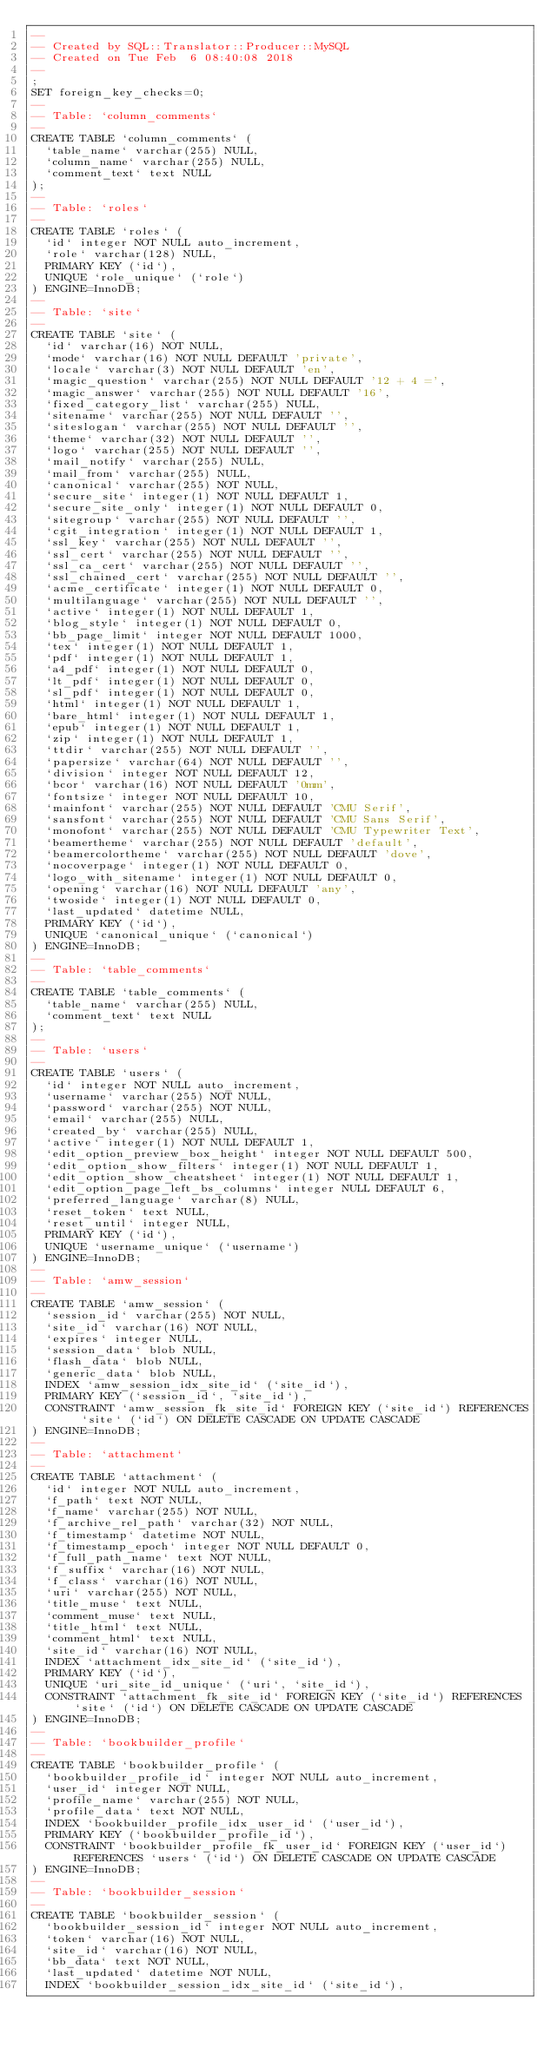<code> <loc_0><loc_0><loc_500><loc_500><_SQL_>-- 
-- Created by SQL::Translator::Producer::MySQL
-- Created on Tue Feb  6 08:40:08 2018
-- 
;
SET foreign_key_checks=0;
--
-- Table: `column_comments`
--
CREATE TABLE `column_comments` (
  `table_name` varchar(255) NULL,
  `column_name` varchar(255) NULL,
  `comment_text` text NULL
);
--
-- Table: `roles`
--
CREATE TABLE `roles` (
  `id` integer NOT NULL auto_increment,
  `role` varchar(128) NULL,
  PRIMARY KEY (`id`),
  UNIQUE `role_unique` (`role`)
) ENGINE=InnoDB;
--
-- Table: `site`
--
CREATE TABLE `site` (
  `id` varchar(16) NOT NULL,
  `mode` varchar(16) NOT NULL DEFAULT 'private',
  `locale` varchar(3) NOT NULL DEFAULT 'en',
  `magic_question` varchar(255) NOT NULL DEFAULT '12 + 4 =',
  `magic_answer` varchar(255) NOT NULL DEFAULT '16',
  `fixed_category_list` varchar(255) NULL,
  `sitename` varchar(255) NOT NULL DEFAULT '',
  `siteslogan` varchar(255) NOT NULL DEFAULT '',
  `theme` varchar(32) NOT NULL DEFAULT '',
  `logo` varchar(255) NOT NULL DEFAULT '',
  `mail_notify` varchar(255) NULL,
  `mail_from` varchar(255) NULL,
  `canonical` varchar(255) NOT NULL,
  `secure_site` integer(1) NOT NULL DEFAULT 1,
  `secure_site_only` integer(1) NOT NULL DEFAULT 0,
  `sitegroup` varchar(255) NOT NULL DEFAULT '',
  `cgit_integration` integer(1) NOT NULL DEFAULT 1,
  `ssl_key` varchar(255) NOT NULL DEFAULT '',
  `ssl_cert` varchar(255) NOT NULL DEFAULT '',
  `ssl_ca_cert` varchar(255) NOT NULL DEFAULT '',
  `ssl_chained_cert` varchar(255) NOT NULL DEFAULT '',
  `acme_certificate` integer(1) NOT NULL DEFAULT 0,
  `multilanguage` varchar(255) NOT NULL DEFAULT '',
  `active` integer(1) NOT NULL DEFAULT 1,
  `blog_style` integer(1) NOT NULL DEFAULT 0,
  `bb_page_limit` integer NOT NULL DEFAULT 1000,
  `tex` integer(1) NOT NULL DEFAULT 1,
  `pdf` integer(1) NOT NULL DEFAULT 1,
  `a4_pdf` integer(1) NOT NULL DEFAULT 0,
  `lt_pdf` integer(1) NOT NULL DEFAULT 0,
  `sl_pdf` integer(1) NOT NULL DEFAULT 0,
  `html` integer(1) NOT NULL DEFAULT 1,
  `bare_html` integer(1) NOT NULL DEFAULT 1,
  `epub` integer(1) NOT NULL DEFAULT 1,
  `zip` integer(1) NOT NULL DEFAULT 1,
  `ttdir` varchar(255) NOT NULL DEFAULT '',
  `papersize` varchar(64) NOT NULL DEFAULT '',
  `division` integer NOT NULL DEFAULT 12,
  `bcor` varchar(16) NOT NULL DEFAULT '0mm',
  `fontsize` integer NOT NULL DEFAULT 10,
  `mainfont` varchar(255) NOT NULL DEFAULT 'CMU Serif',
  `sansfont` varchar(255) NOT NULL DEFAULT 'CMU Sans Serif',
  `monofont` varchar(255) NOT NULL DEFAULT 'CMU Typewriter Text',
  `beamertheme` varchar(255) NOT NULL DEFAULT 'default',
  `beamercolortheme` varchar(255) NOT NULL DEFAULT 'dove',
  `nocoverpage` integer(1) NOT NULL DEFAULT 0,
  `logo_with_sitename` integer(1) NOT NULL DEFAULT 0,
  `opening` varchar(16) NOT NULL DEFAULT 'any',
  `twoside` integer(1) NOT NULL DEFAULT 0,
  `last_updated` datetime NULL,
  PRIMARY KEY (`id`),
  UNIQUE `canonical_unique` (`canonical`)
) ENGINE=InnoDB;
--
-- Table: `table_comments`
--
CREATE TABLE `table_comments` (
  `table_name` varchar(255) NULL,
  `comment_text` text NULL
);
--
-- Table: `users`
--
CREATE TABLE `users` (
  `id` integer NOT NULL auto_increment,
  `username` varchar(255) NOT NULL,
  `password` varchar(255) NOT NULL,
  `email` varchar(255) NULL,
  `created_by` varchar(255) NULL,
  `active` integer(1) NOT NULL DEFAULT 1,
  `edit_option_preview_box_height` integer NOT NULL DEFAULT 500,
  `edit_option_show_filters` integer(1) NOT NULL DEFAULT 1,
  `edit_option_show_cheatsheet` integer(1) NOT NULL DEFAULT 1,
  `edit_option_page_left_bs_columns` integer NULL DEFAULT 6,
  `preferred_language` varchar(8) NULL,
  `reset_token` text NULL,
  `reset_until` integer NULL,
  PRIMARY KEY (`id`),
  UNIQUE `username_unique` (`username`)
) ENGINE=InnoDB;
--
-- Table: `amw_session`
--
CREATE TABLE `amw_session` (
  `session_id` varchar(255) NOT NULL,
  `site_id` varchar(16) NOT NULL,
  `expires` integer NULL,
  `session_data` blob NULL,
  `flash_data` blob NULL,
  `generic_data` blob NULL,
  INDEX `amw_session_idx_site_id` (`site_id`),
  PRIMARY KEY (`session_id`, `site_id`),
  CONSTRAINT `amw_session_fk_site_id` FOREIGN KEY (`site_id`) REFERENCES `site` (`id`) ON DELETE CASCADE ON UPDATE CASCADE
) ENGINE=InnoDB;
--
-- Table: `attachment`
--
CREATE TABLE `attachment` (
  `id` integer NOT NULL auto_increment,
  `f_path` text NOT NULL,
  `f_name` varchar(255) NOT NULL,
  `f_archive_rel_path` varchar(32) NOT NULL,
  `f_timestamp` datetime NOT NULL,
  `f_timestamp_epoch` integer NOT NULL DEFAULT 0,
  `f_full_path_name` text NOT NULL,
  `f_suffix` varchar(16) NOT NULL,
  `f_class` varchar(16) NOT NULL,
  `uri` varchar(255) NOT NULL,
  `title_muse` text NULL,
  `comment_muse` text NULL,
  `title_html` text NULL,
  `comment_html` text NULL,
  `site_id` varchar(16) NOT NULL,
  INDEX `attachment_idx_site_id` (`site_id`),
  PRIMARY KEY (`id`),
  UNIQUE `uri_site_id_unique` (`uri`, `site_id`),
  CONSTRAINT `attachment_fk_site_id` FOREIGN KEY (`site_id`) REFERENCES `site` (`id`) ON DELETE CASCADE ON UPDATE CASCADE
) ENGINE=InnoDB;
--
-- Table: `bookbuilder_profile`
--
CREATE TABLE `bookbuilder_profile` (
  `bookbuilder_profile_id` integer NOT NULL auto_increment,
  `user_id` integer NOT NULL,
  `profile_name` varchar(255) NOT NULL,
  `profile_data` text NOT NULL,
  INDEX `bookbuilder_profile_idx_user_id` (`user_id`),
  PRIMARY KEY (`bookbuilder_profile_id`),
  CONSTRAINT `bookbuilder_profile_fk_user_id` FOREIGN KEY (`user_id`) REFERENCES `users` (`id`) ON DELETE CASCADE ON UPDATE CASCADE
) ENGINE=InnoDB;
--
-- Table: `bookbuilder_session`
--
CREATE TABLE `bookbuilder_session` (
  `bookbuilder_session_id` integer NOT NULL auto_increment,
  `token` varchar(16) NOT NULL,
  `site_id` varchar(16) NOT NULL,
  `bb_data` text NOT NULL,
  `last_updated` datetime NOT NULL,
  INDEX `bookbuilder_session_idx_site_id` (`site_id`),</code> 